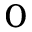Convert formula to latex. <formula><loc_0><loc_0><loc_500><loc_500>_ { 0 }</formula> 